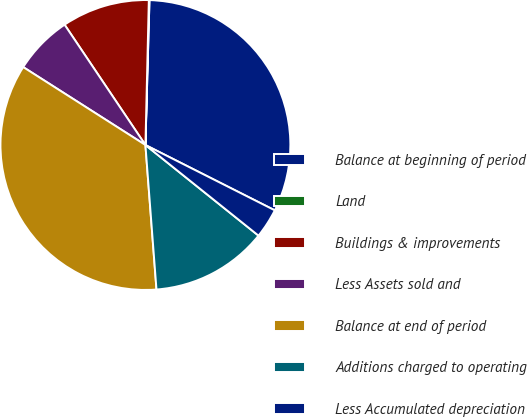Convert chart. <chart><loc_0><loc_0><loc_500><loc_500><pie_chart><fcel>Balance at beginning of period<fcel>Land<fcel>Buildings & improvements<fcel>Less Assets sold and<fcel>Balance at end of period<fcel>Additions charged to operating<fcel>Less Accumulated depreciation<nl><fcel>32.0%<fcel>0.07%<fcel>9.79%<fcel>6.55%<fcel>35.25%<fcel>13.03%<fcel>3.31%<nl></chart> 